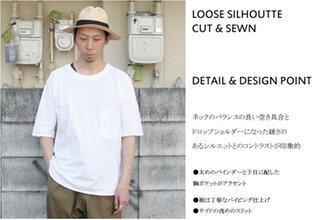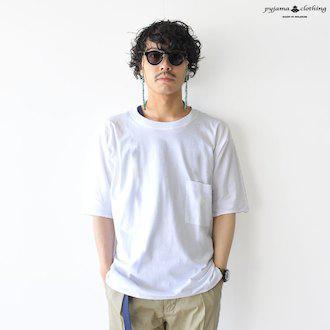The first image is the image on the left, the second image is the image on the right. Assess this claim about the two images: "the white t-shirt in the image on the left has a breast pocket". Correct or not? Answer yes or no. Yes. 